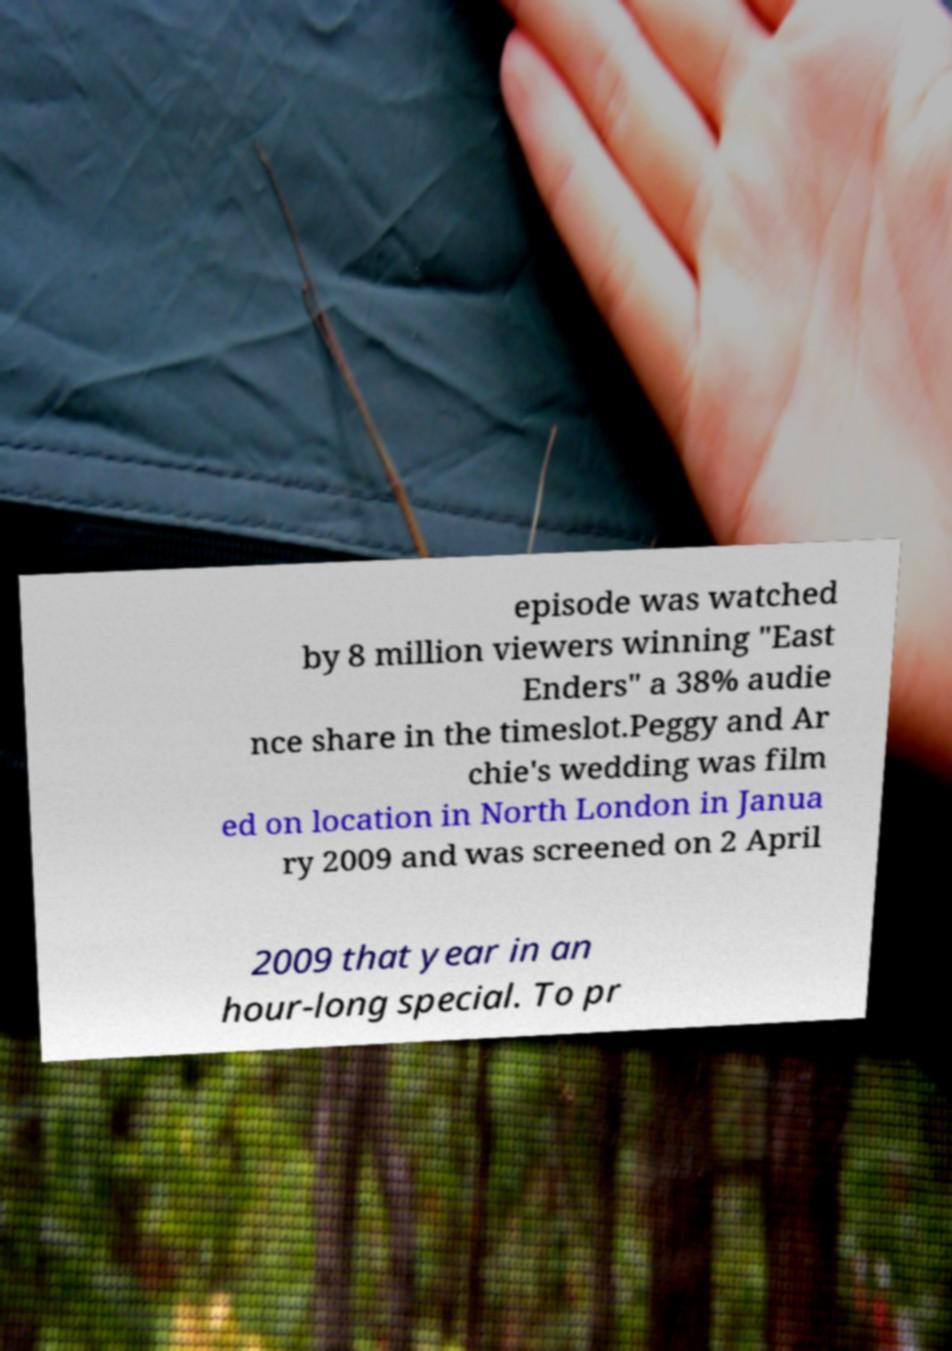Please identify and transcribe the text found in this image. episode was watched by 8 million viewers winning "East Enders" a 38% audie nce share in the timeslot.Peggy and Ar chie's wedding was film ed on location in North London in Janua ry 2009 and was screened on 2 April 2009 that year in an hour-long special. To pr 